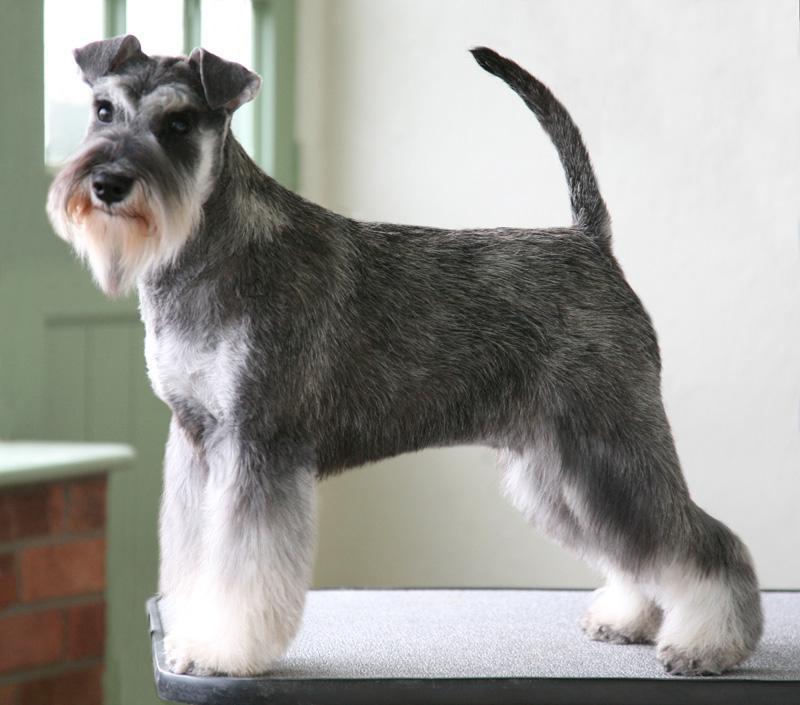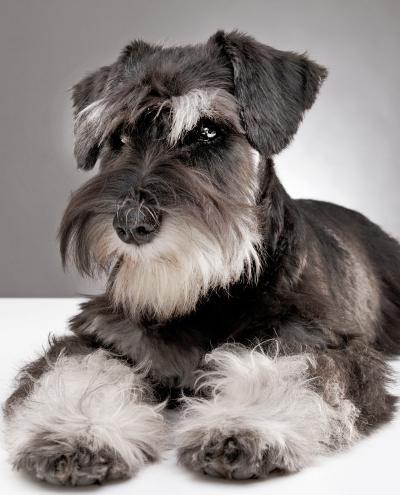The first image is the image on the left, the second image is the image on the right. Examine the images to the left and right. Is the description "there is a dog sitting on a chair indoors" accurate? Answer yes or no. No. The first image is the image on the left, the second image is the image on the right. For the images displayed, is the sentence "Exactly one dog is sitting." factually correct? Answer yes or no. No. 